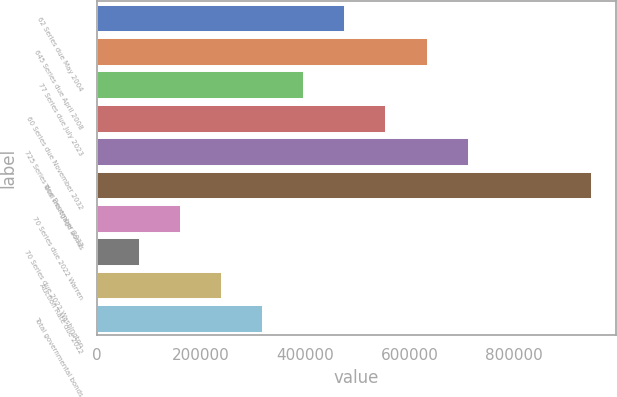Convert chart to OTSL. <chart><loc_0><loc_0><loc_500><loc_500><bar_chart><fcel>62 Series due May 2004<fcel>645 Series due April 2008<fcel>77 Series due July 2023<fcel>60 Series due November 2032<fcel>725 Series due December 2032<fcel>Total mortgage bonds<fcel>70 Series due 2022 Warren<fcel>70 Series due 2022 Washington<fcel>Auction Rate due 2022<fcel>Total governmental bonds<nl><fcel>474887<fcel>632874<fcel>395894<fcel>553880<fcel>711868<fcel>948848<fcel>158913<fcel>79919.5<fcel>237906<fcel>316900<nl></chart> 